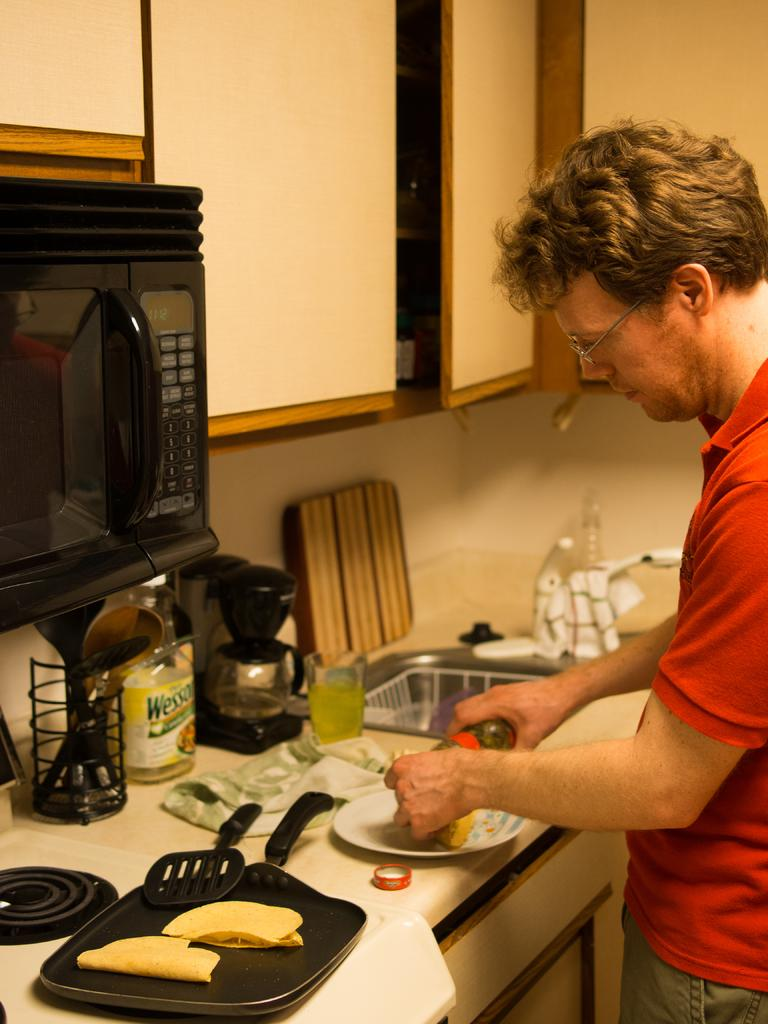<image>
Provide a brief description of the given image. A man fixing a meal and a bottle of Wesson cooking oil. 